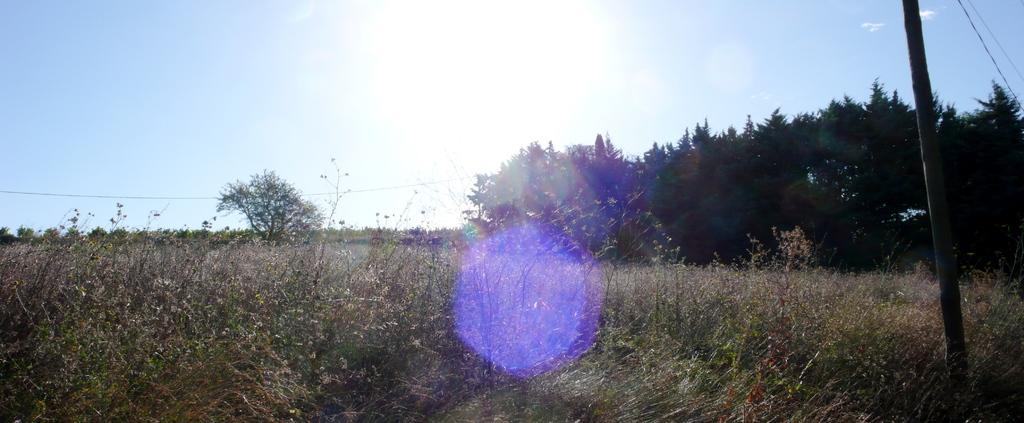What type of vegetation can be seen in the image? There is grass and plants in the image. What other objects can be seen in the image? There is a pole in the image. What else is visible in the image? There are trees in the image. What can be seen in the background of the image? The sky is visible in the background of the image. What is the price of the goat in the image? There is no goat present in the image, so it is not possible to determine its price. 